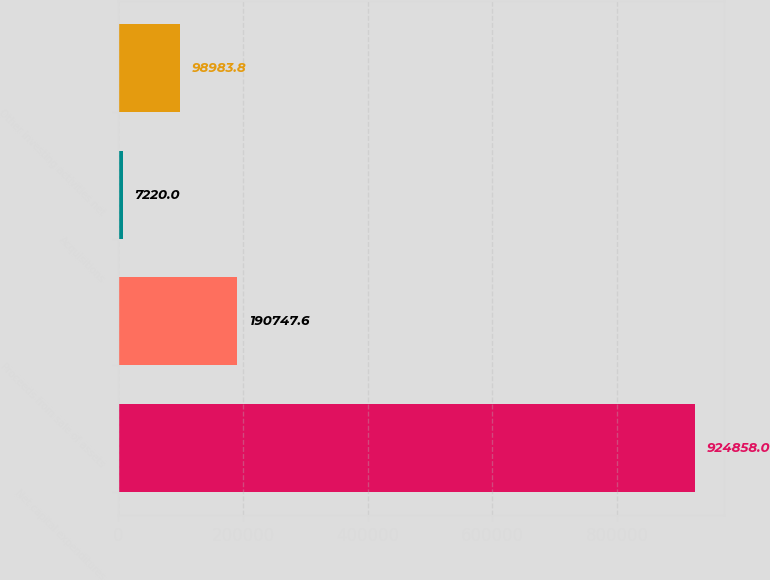<chart> <loc_0><loc_0><loc_500><loc_500><bar_chart><fcel>Net capital expenditures<fcel>Proceeds from sale of assets<fcel>Acquisitions<fcel>Other investing activities net<nl><fcel>924858<fcel>190748<fcel>7220<fcel>98983.8<nl></chart> 